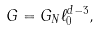Convert formula to latex. <formula><loc_0><loc_0><loc_500><loc_500>G = G _ { N } \ell _ { 0 } ^ { d - 3 } ,</formula> 